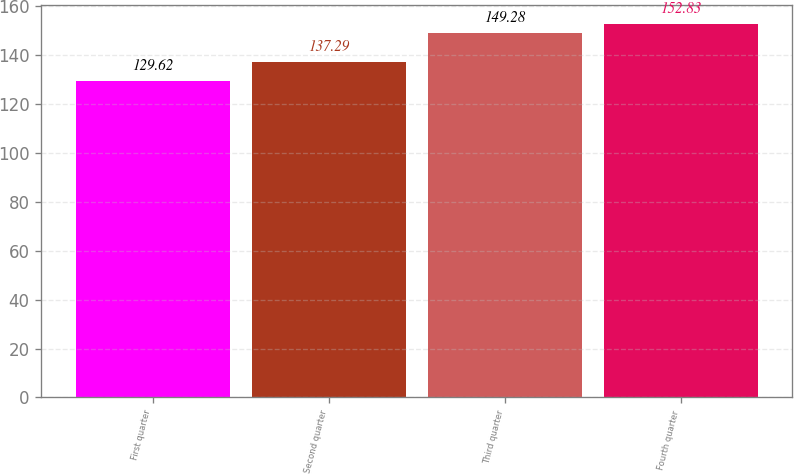Convert chart. <chart><loc_0><loc_0><loc_500><loc_500><bar_chart><fcel>First quarter<fcel>Second quarter<fcel>Third quarter<fcel>Fourth quarter<nl><fcel>129.62<fcel>137.29<fcel>149.28<fcel>152.83<nl></chart> 